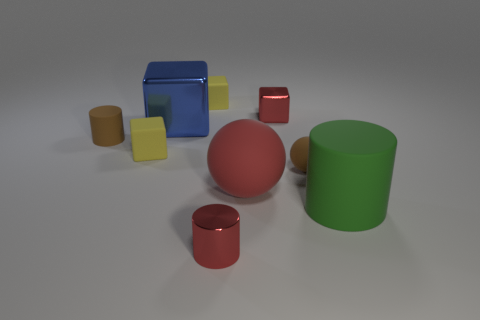Add 1 red shiny things. How many objects exist? 10 Subtract all cubes. How many objects are left? 5 Add 4 small gray rubber spheres. How many small gray rubber spheres exist? 4 Subtract 0 gray cylinders. How many objects are left? 9 Subtract all tiny gray metal balls. Subtract all green rubber things. How many objects are left? 8 Add 2 brown things. How many brown things are left? 4 